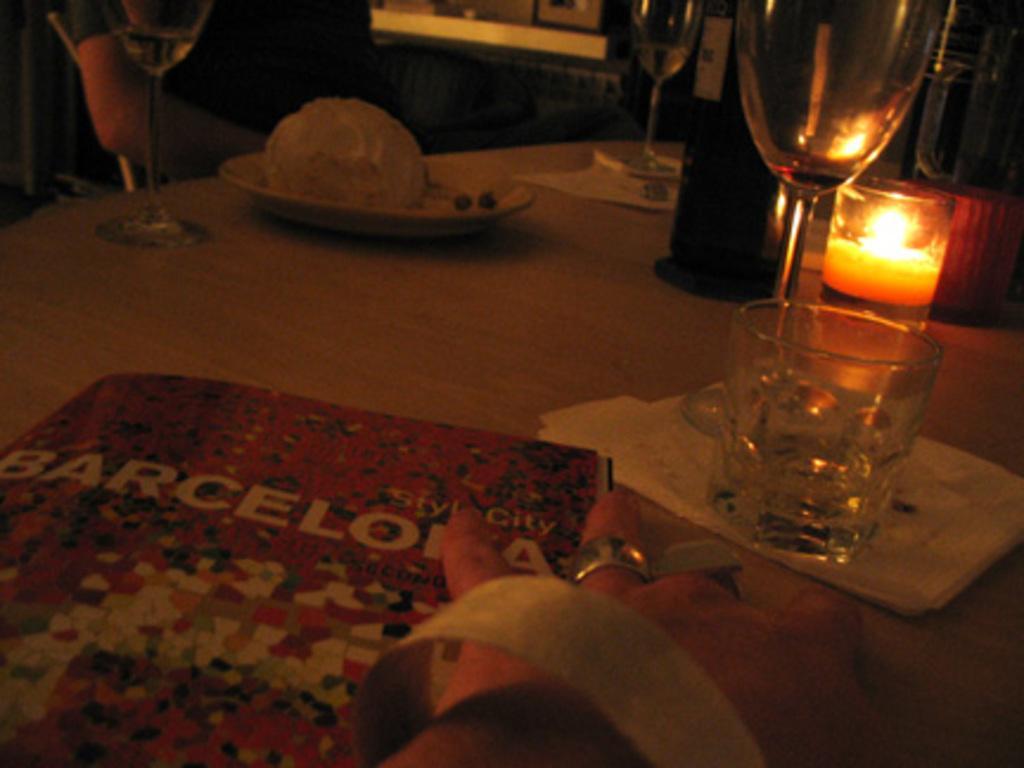Please provide a concise description of this image. On a table,there is a food item,a candle,bottles and glasses and a book are kept and beside the book there is a hand of a person. 